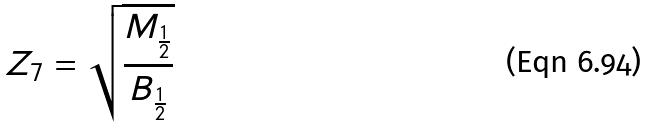Convert formula to latex. <formula><loc_0><loc_0><loc_500><loc_500>Z _ { 7 } = \sqrt { \frac { M _ { \frac { 1 } { 2 } } } { B _ { \frac { 1 } { 2 } } } }</formula> 